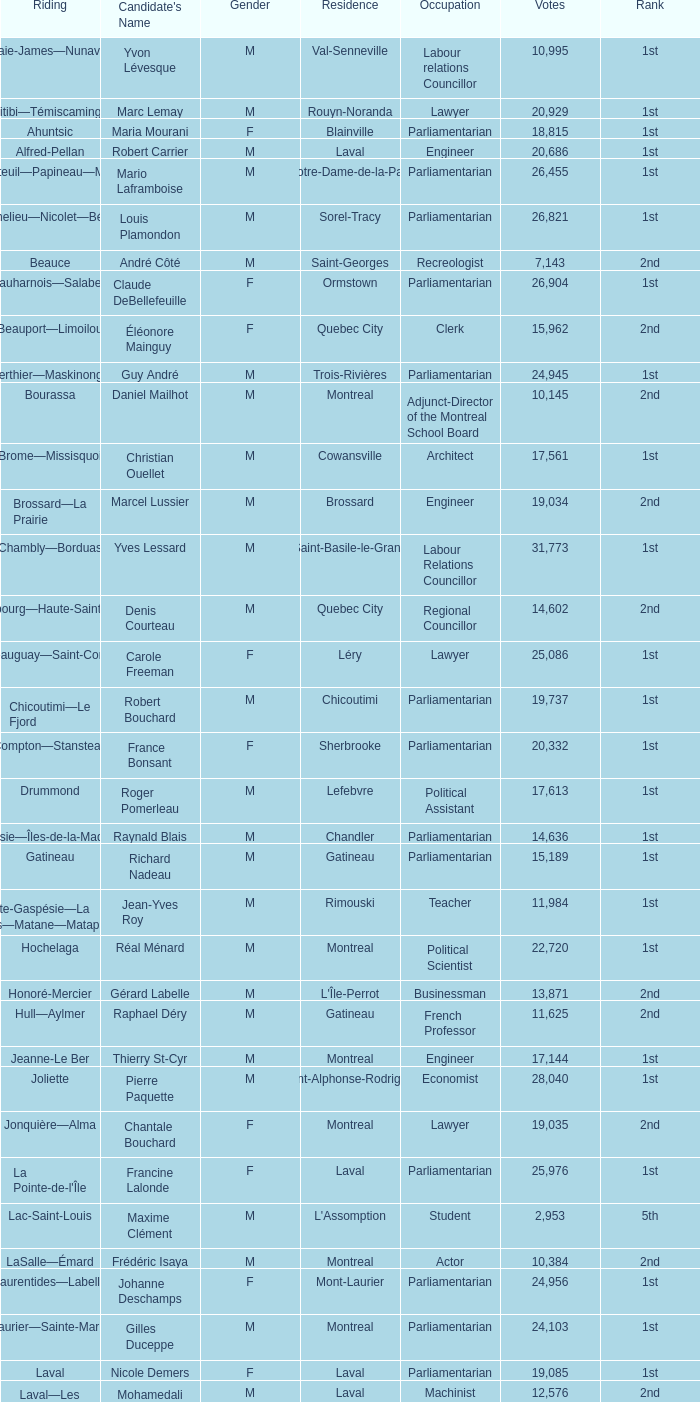Which gender does luc desnoyers belong to? M. 